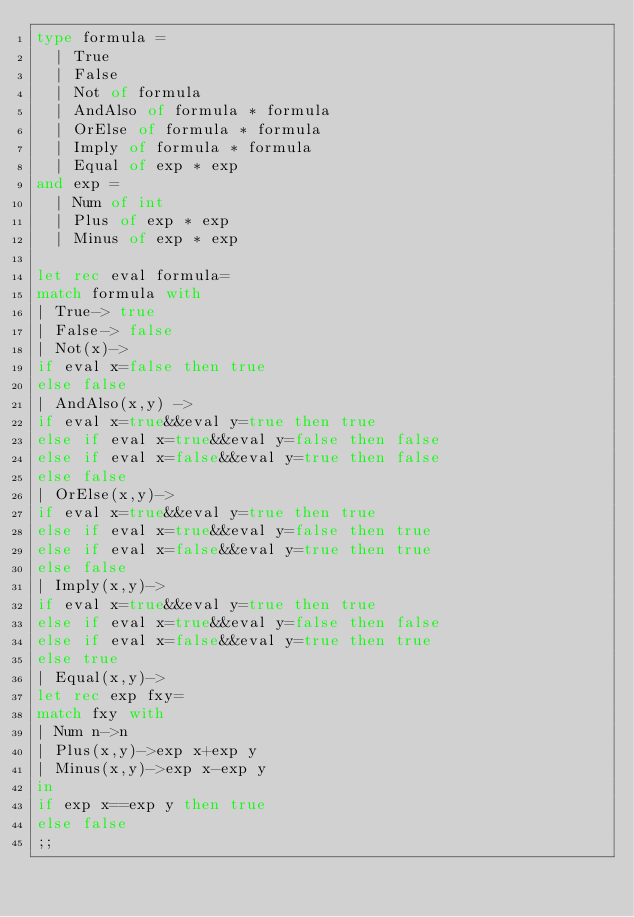<code> <loc_0><loc_0><loc_500><loc_500><_OCaml_>type formula =
	| True
	| False
	| Not of formula
	| AndAlso of formula * formula
	| OrElse of formula * formula
	| Imply of formula * formula
	| Equal of exp * exp
and exp =
	| Num of int
	| Plus of exp * exp
	| Minus of exp * exp

let rec eval formula=
match formula with
| True-> true
| False-> false
| Not(x)->
if eval x=false then true
else false
| AndAlso(x,y) ->
if eval x=true&&eval y=true then true
else if eval x=true&&eval y=false then false
else if eval x=false&&eval y=true then false
else false
| OrElse(x,y)->
if eval x=true&&eval y=true then true
else if eval x=true&&eval y=false then true
else if eval x=false&&eval y=true then true
else false
| Imply(x,y)->
if eval x=true&&eval y=true then true
else if eval x=true&&eval y=false then false
else if eval x=false&&eval y=true then true
else true
| Equal(x,y)->
let rec exp fxy=
match fxy with
| Num n->n
| Plus(x,y)->exp x+exp y
| Minus(x,y)->exp x-exp y
in
if exp x==exp y then true
else false
;;
</code> 